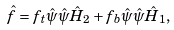Convert formula to latex. <formula><loc_0><loc_0><loc_500><loc_500>\hat { f } = f _ { t } \hat { \psi } \hat { \psi } \hat { H } _ { 2 } + f _ { b } \hat { \psi } \hat { \psi } \hat { H } _ { 1 } ,</formula> 